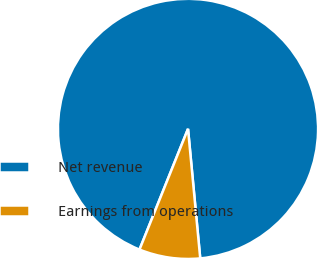Convert chart. <chart><loc_0><loc_0><loc_500><loc_500><pie_chart><fcel>Net revenue<fcel>Earnings from operations<nl><fcel>92.42%<fcel>7.58%<nl></chart> 